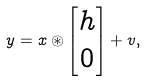<formula> <loc_0><loc_0><loc_500><loc_500>y = x \circledast \begin{bmatrix} h \\ 0 \end{bmatrix} + v ,</formula> 